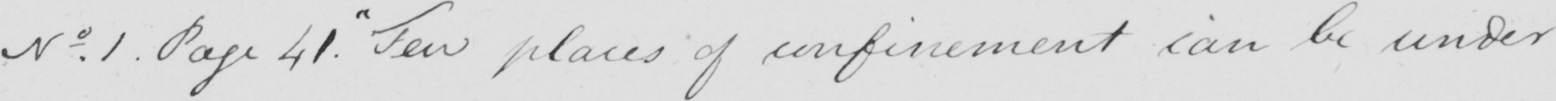Transcribe the text shown in this historical manuscript line. No . 1 . Page 41 .  " Few places of confinement can be under 